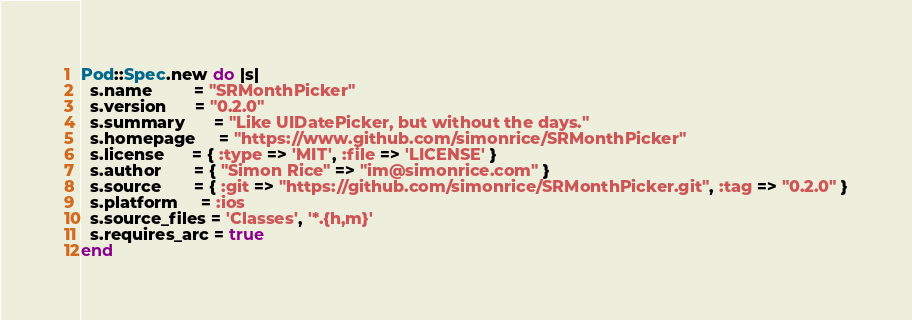Convert code to text. <code><loc_0><loc_0><loc_500><loc_500><_Ruby_>Pod::Spec.new do |s|
  s.name         = "SRMonthPicker"
  s.version      = "0.2.0"
  s.summary      = "Like UIDatePicker, but without the days."
  s.homepage     = "https://www.github.com/simonrice/SRMonthPicker"
  s.license      = { :type => 'MIT', :file => 'LICENSE' }
  s.author       = { "Simon Rice" => "im@simonrice.com" }
  s.source       = { :git => "https://github.com/simonrice/SRMonthPicker.git", :tag => "0.2.0" }
  s.platform     = :ios
  s.source_files = 'Classes', '*.{h,m}'
  s.requires_arc = true
end
</code> 